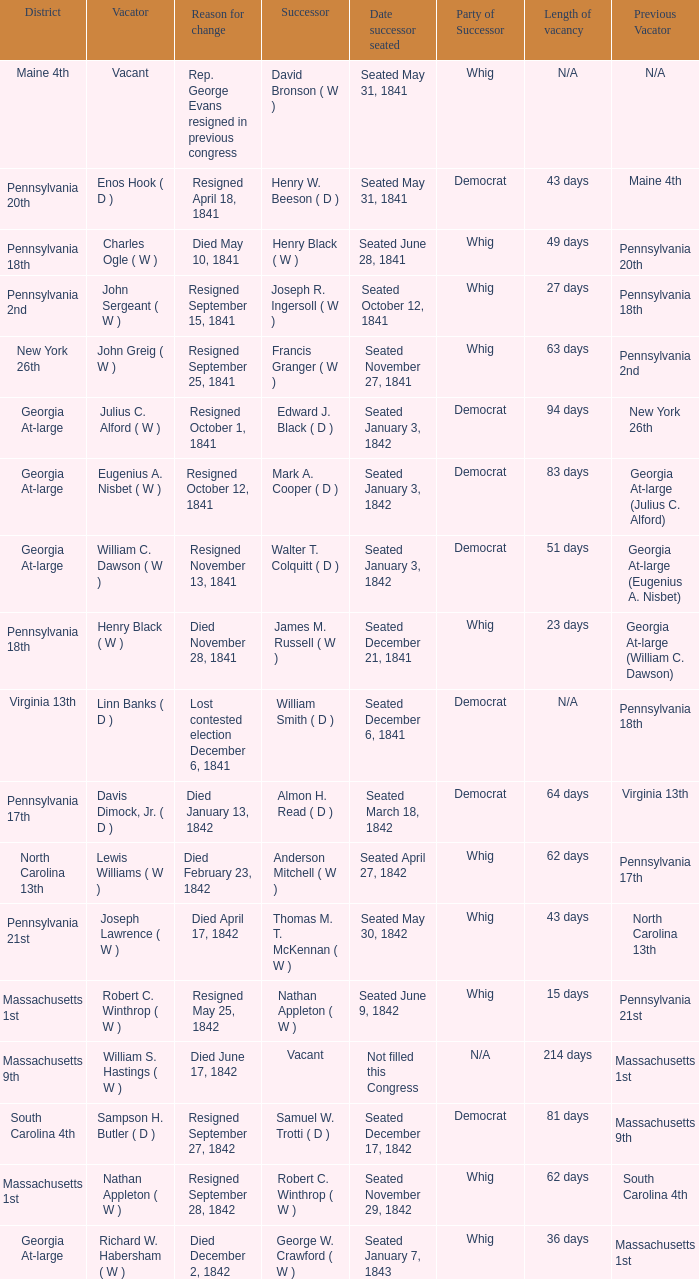Name the date successor seated for pennsylvania 17th Seated March 18, 1842. 